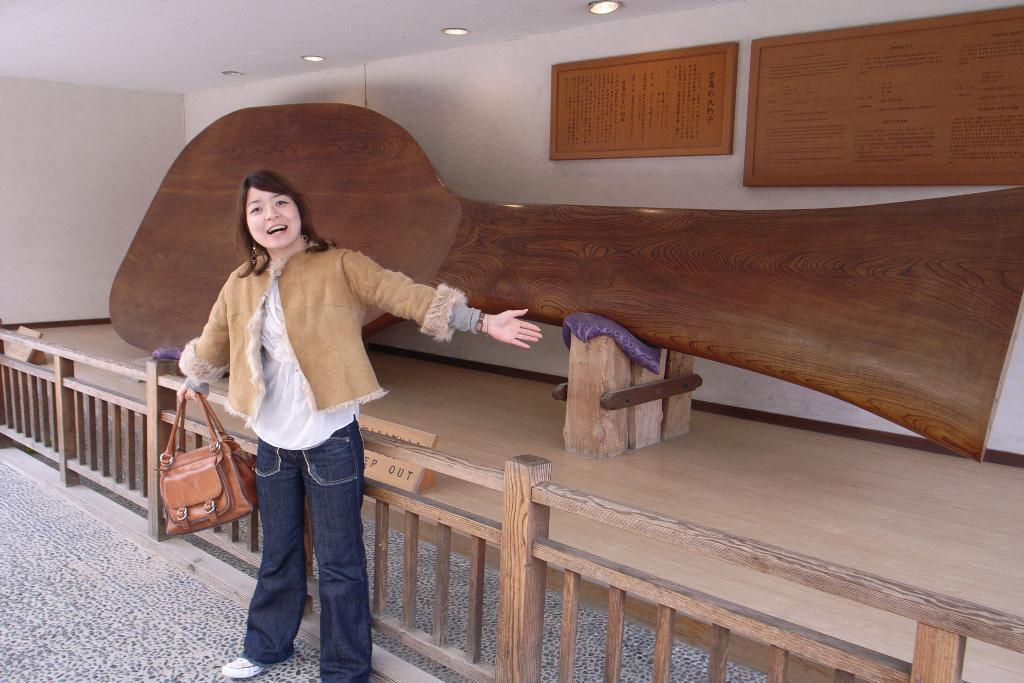Who is present in the image? There is a woman in the image. What is the woman holding? The woman is holding a handbag. What is the woman's facial expression? The woman is smiling. What type of barrier can be seen in the image? There is a wooden fence in the image. What type of lace is the woman wearing in the image? There is no lace visible on the woman in the image. 